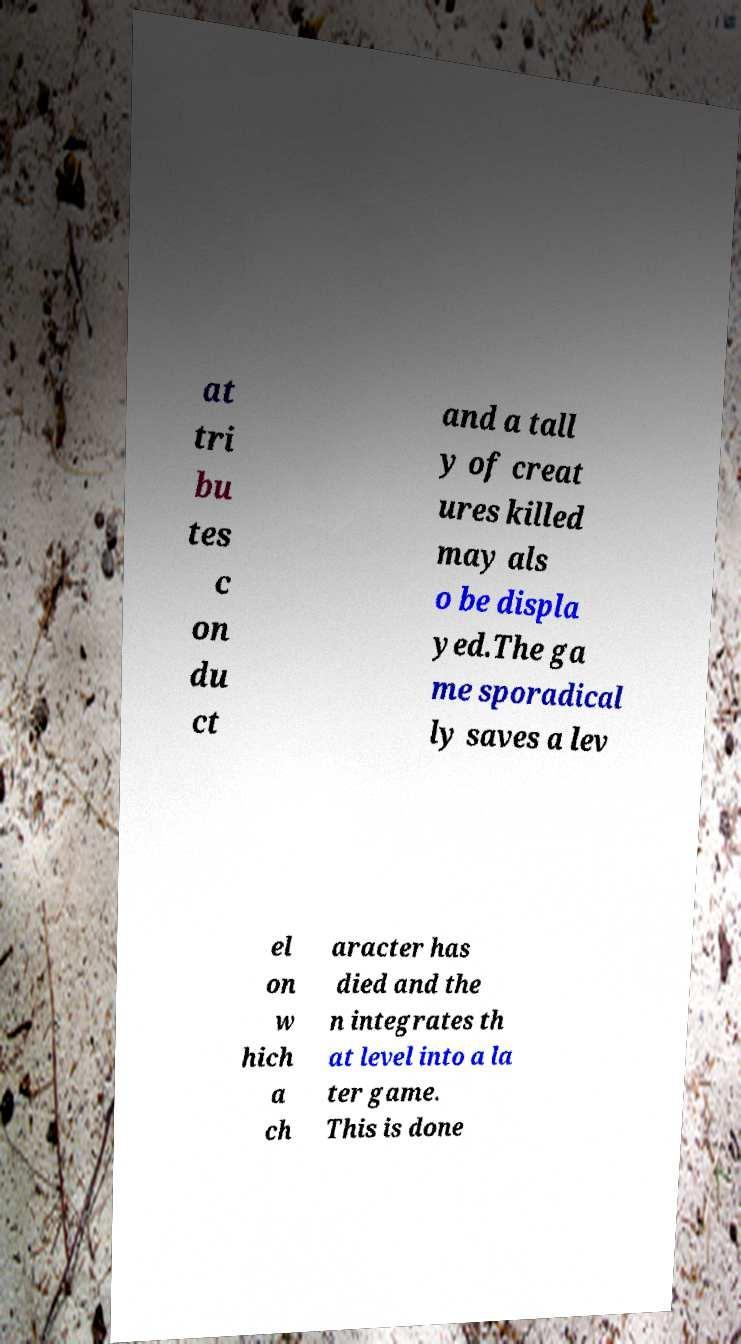For documentation purposes, I need the text within this image transcribed. Could you provide that? at tri bu tes c on du ct and a tall y of creat ures killed may als o be displa yed.The ga me sporadical ly saves a lev el on w hich a ch aracter has died and the n integrates th at level into a la ter game. This is done 